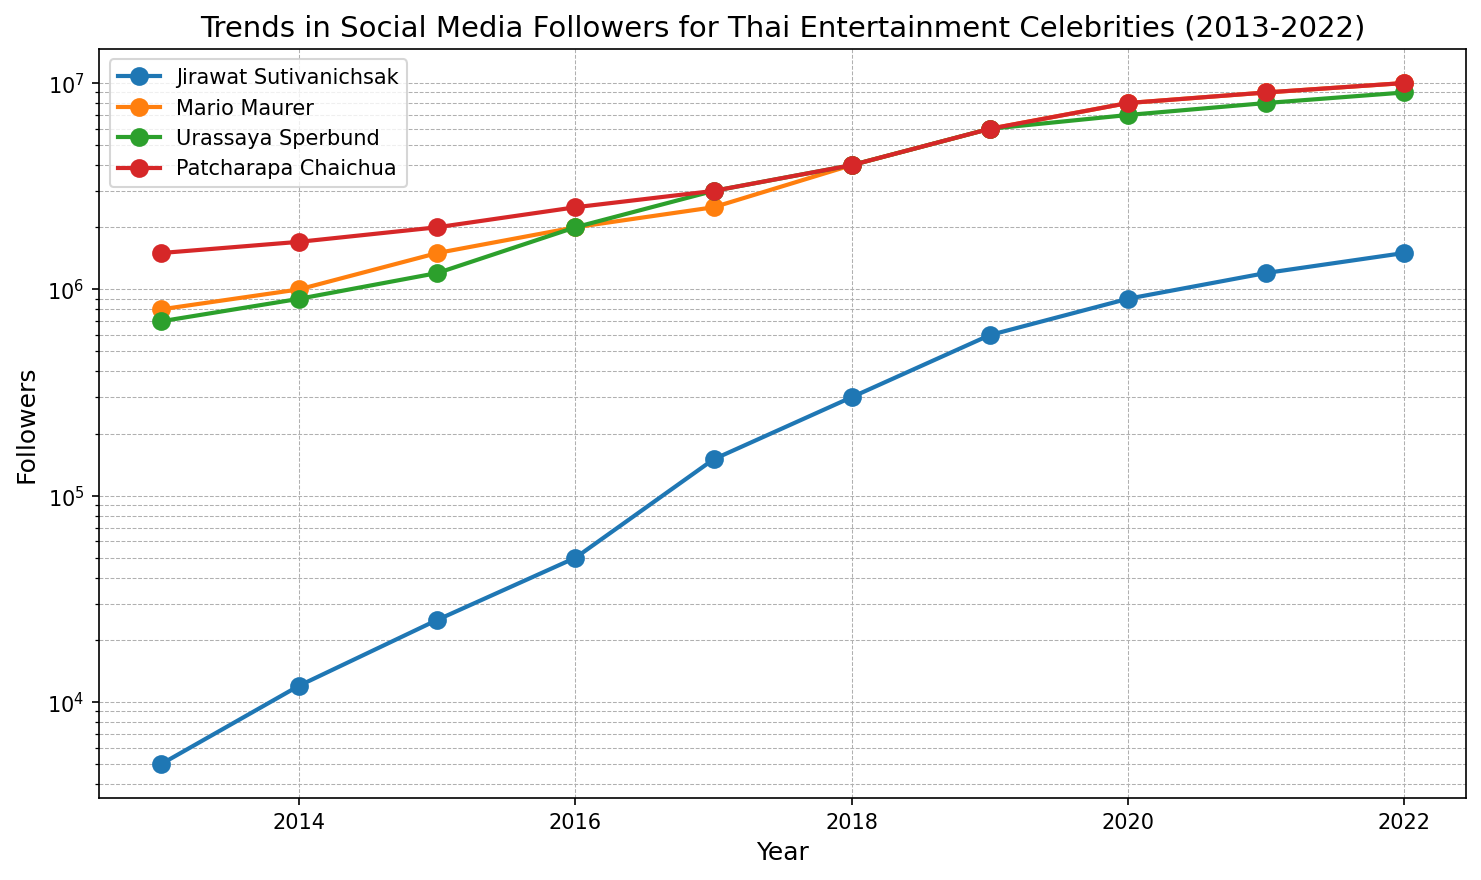What's the trend in Jirawat Sutivanichsak's follower growth over the years? To determine the trend, observe the rise in data points for Jirawat Sutivanichsak from 2013 to 2022. The numbers grow exponentially, indicating a rapid increase year over year.
Answer: Rapid increase How does Mario Maurer's follower growth compare to Jirawat Sutivanichsak's during 2013-2022? Compare the curves of both celebrities. Mario Maurer's followers start at a higher number and maintain a high growth rate but Jirawat Sutivanichsak's growth rate is also exponential though starting from a smaller base.
Answer: Mario started higher but both show exponential growth Who had the highest number of followers in 2019? Locate the follower data for 2019 across all celebrities. Mario Maurer and Patcharapa Chaichua both had 6,000,000 followers, the highest among the listed celebrities for that year.
Answer: Mario Maurer and Patcharapa Chaichua Between Urassaya Sperbund and Patcharapa Chaichua, who experienced a greater increase in followers from 2013 to 2022? Compare the increase in followers from 2013 to 2022 for both. Urassaya Sperbund increases from 700,000 to 9,000,000 (8,300,000 increase), while Patcharapa Chaichua increases from 1,500,000 to 10,000,000 (8,500,000 increase).
Answer: Patcharapa Chaichua What's the average number of followers for Jirawat Sutivanichsak over the decade? Sum the follower counts for each year from 2013 to 2022 and divide by 10. (5000 + 12000 + 25000 + 50000 + 150000 + 300000 + 600000 + 900000 + 1200000 + 1500000) / 10 = 408,200.
Answer: 408,200 In which year did Jirawat Sutivanichsak reach 1 million followers? Locate the point where Jirawat Sutivanichsak's follower count exceeds 1,000,000. This occurs between 2019 and 2020.
Answer: 2020 Which celebrity had the least followers in 2013? Look at the follower counts for all celebrities in 2013. Jirawat Sutivanichsak had the lowest number of followers with 5,000.
Answer: Jirawat Sutivanichsak Comparing the growth rates, which celebrity's social media following grew the fastest between 2016 and 2017? Check the difference in followers between 2016 and 2017. Jirawat Sutivanichsak gained 100,000 followers, Mario Maurer gained 500,000, Urassaya Sperbund gained 1,000,000, and Patcharapa Chaichua gained 500,000. Urassaya Sperbund showed the fastest growth.
Answer: Urassaya Sperbund 